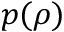<formula> <loc_0><loc_0><loc_500><loc_500>p ( \rho )</formula> 